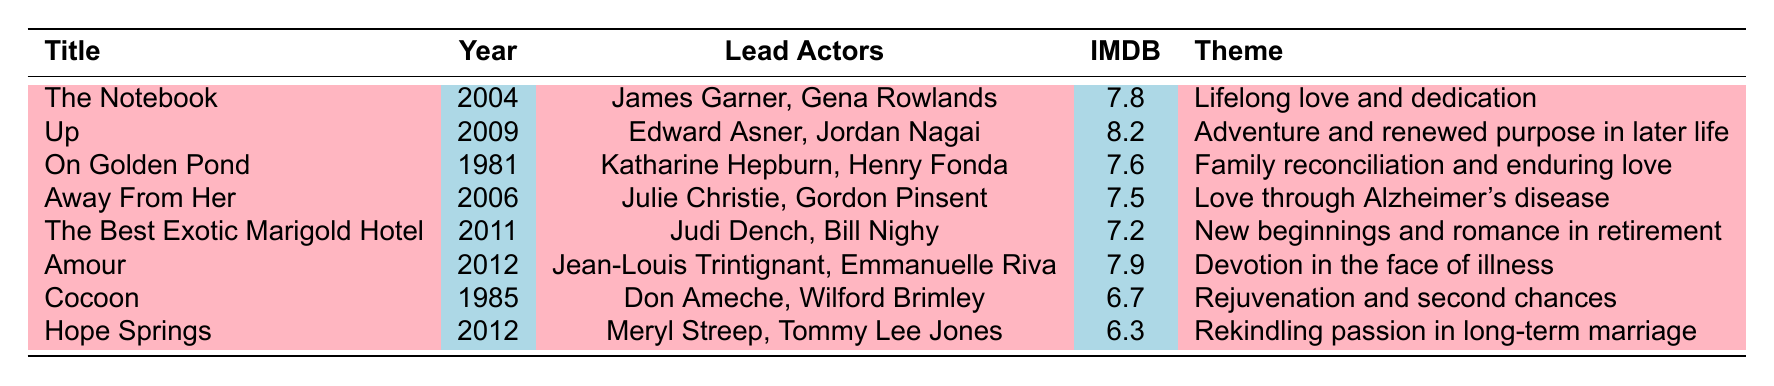What is the title of the highest-rated movie featuring elderly couples? The highest IMDB rating in the table is 8.2, which corresponds to the movie titled "Up".
Answer: Up Which year was "On Golden Pond" released? By looking at the table, "On Golden Pond" is listed under the year 1981.
Answer: 1981 What are the lead actors in "The Best Exotic Marigold Hotel"? The table indicates that the lead actors for "The Best Exotic Marigold Hotel" are Judi Dench and Bill Nighy.
Answer: Judi Dench, Bill Nighy Is "Cocoon" rated higher than "Hope Springs"? The IMDB rating for "Cocoon" is 6.7, while for "Hope Springs," it is 6.3. Since 6.7 is greater than 6.3, "Cocoon" is rated higher.
Answer: Yes How many movies in the table have an IMDB rating above 7.5? The movies with ratings above 7.5 are "Up" (8.2), "The Notebook" (7.8), "Amour" (7.9), and "On Golden Pond" (7.6). There are a total of 4 movies fitting this criterion.
Answer: 4 Which movie has the theme of "Love through Alzheimer's disease"? Checking the table, "Away From Her" matches the theme "Love through Alzheimer's disease".
Answer: Away From Her What is the average IMDB rating of the movies listed? First, we sum the ratings: 7.8 + 8.2 + 7.6 + 7.5 + 7.2 + 7.9 + 6.7 + 6.3 = 59.2. There are 8 movies, so the average is 59.2 / 8 = 7.4.
Answer: 7.4 Which movie released in 2012 features Meryl Streep? The table indicates that "Hope Springs," released in 2012, features Meryl Streep.
Answer: Hope Springs What theme is associated with "Amour"? According to the table, the theme associated with "Amour" is "Devotion in the face of illness".
Answer: Devotion in the face of illness Which movie features both a romantic theme and a focus on new beginnings? "The Best Exotic Marigold Hotel" corresponds to the theme of new beginnings and romance in retirement.
Answer: The Best Exotic Marigold Hotel 